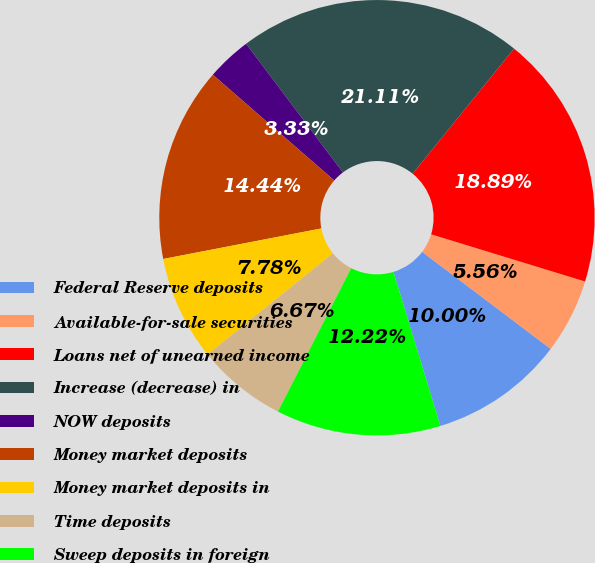Convert chart to OTSL. <chart><loc_0><loc_0><loc_500><loc_500><pie_chart><fcel>Federal Reserve deposits<fcel>Available-for-sale securities<fcel>Loans net of unearned income<fcel>Increase (decrease) in<fcel>NOW deposits<fcel>Money market deposits<fcel>Money market deposits in<fcel>Time deposits<fcel>Sweep deposits in foreign<nl><fcel>10.0%<fcel>5.56%<fcel>18.89%<fcel>21.11%<fcel>3.33%<fcel>14.44%<fcel>7.78%<fcel>6.67%<fcel>12.22%<nl></chart> 